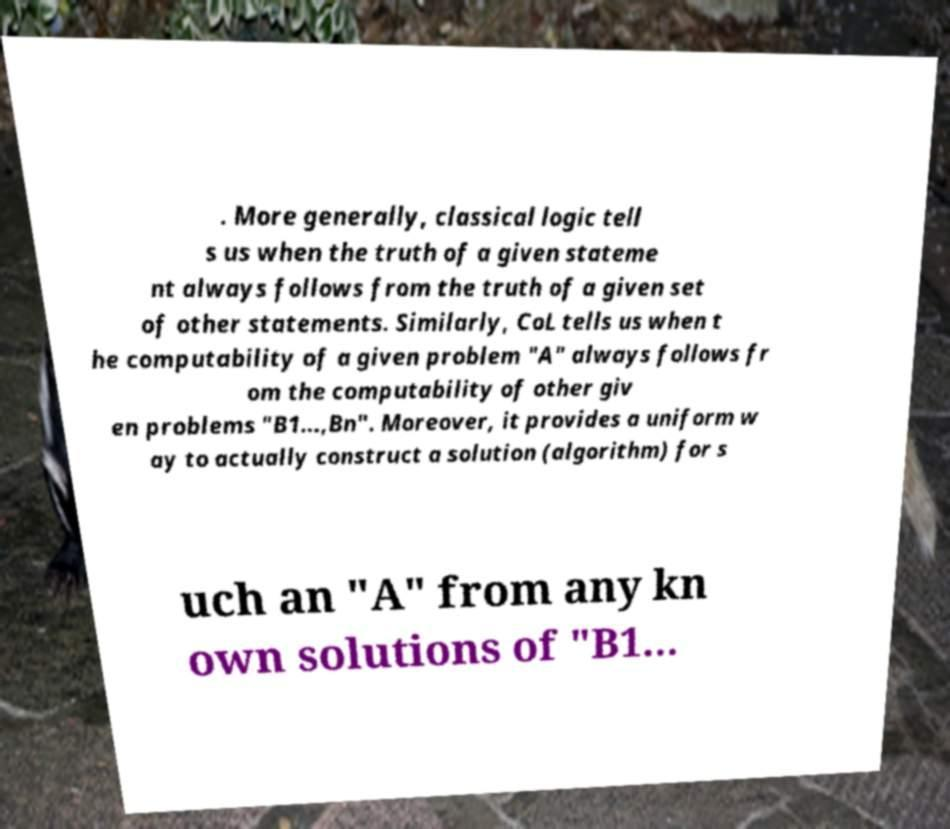Please identify and transcribe the text found in this image. . More generally, classical logic tell s us when the truth of a given stateme nt always follows from the truth of a given set of other statements. Similarly, CoL tells us when t he computability of a given problem "A" always follows fr om the computability of other giv en problems "B1...,Bn". Moreover, it provides a uniform w ay to actually construct a solution (algorithm) for s uch an "A" from any kn own solutions of "B1... 